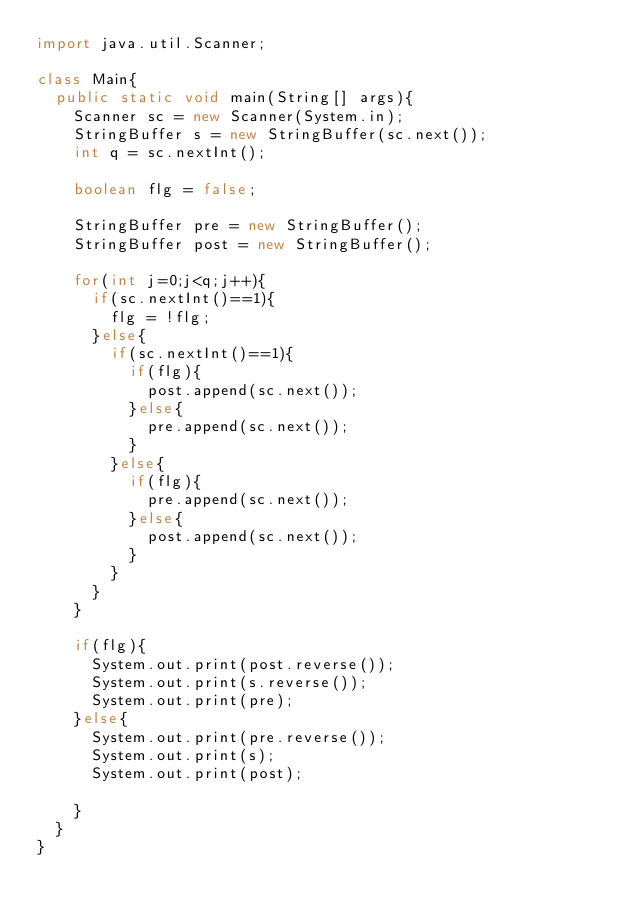<code> <loc_0><loc_0><loc_500><loc_500><_Java_>import java.util.Scanner;

class Main{
  public static void main(String[] args){
    Scanner sc = new Scanner(System.in);
    StringBuffer s = new StringBuffer(sc.next());
    int q = sc.nextInt();
    
    boolean flg = false;

    StringBuffer pre = new StringBuffer();
    StringBuffer post = new StringBuffer();
       
    for(int j=0;j<q;j++){
      if(sc.nextInt()==1){
        flg = !flg;
      }else{
        if(sc.nextInt()==1){
          if(flg){
            post.append(sc.next());
          }else{
            pre.append(sc.next());
          }
        }else{
          if(flg){
            pre.append(sc.next());
          }else{
            post.append(sc.next());
          }
        }
      }
    }

    if(flg){
      System.out.print(post.reverse());
      System.out.print(s.reverse());
      System.out.print(pre);
    }else{
      System.out.print(pre.reverse());
      System.out.print(s);
      System.out.print(post);

    }
  }
}</code> 